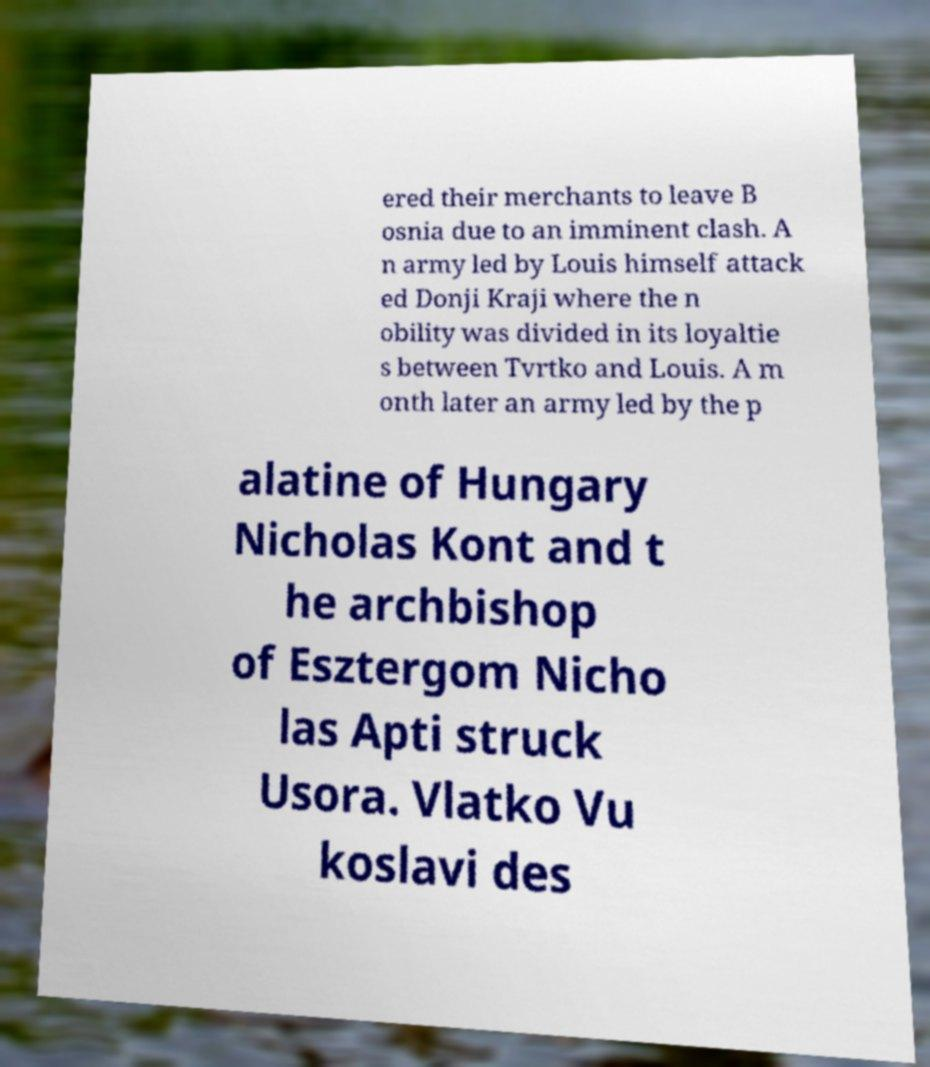What messages or text are displayed in this image? I need them in a readable, typed format. ered their merchants to leave B osnia due to an imminent clash. A n army led by Louis himself attack ed Donji Kraji where the n obility was divided in its loyaltie s between Tvrtko and Louis. A m onth later an army led by the p alatine of Hungary Nicholas Kont and t he archbishop of Esztergom Nicho las Apti struck Usora. Vlatko Vu koslavi des 